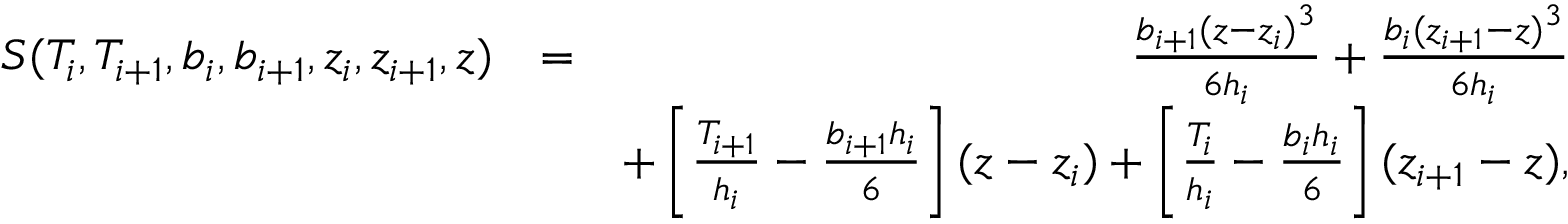Convert formula to latex. <formula><loc_0><loc_0><loc_500><loc_500>\begin{array} { r l r } { S ( T _ { i } , T _ { i + 1 } , b _ { i } , b _ { i + 1 } , z _ { i } , z _ { i + 1 } , z ) } & { = } & { \frac { b _ { i + 1 } ( z - z _ { i } ) ^ { 3 } } { 6 h _ { i } } + \frac { b _ { i } ( z _ { i + 1 } - z ) ^ { 3 } } { 6 h _ { i } } } \\ & { + \left [ \frac { T _ { i + 1 } } { h _ { i } } - \frac { b _ { i + 1 } h _ { i } } { 6 } \right ] ( z - z _ { i } ) + \left [ \frac { T _ { i } } { h _ { i } } - \frac { b _ { i } h _ { i } } { 6 } \right ] ( z _ { i + 1 } - z ) , } \end{array}</formula> 